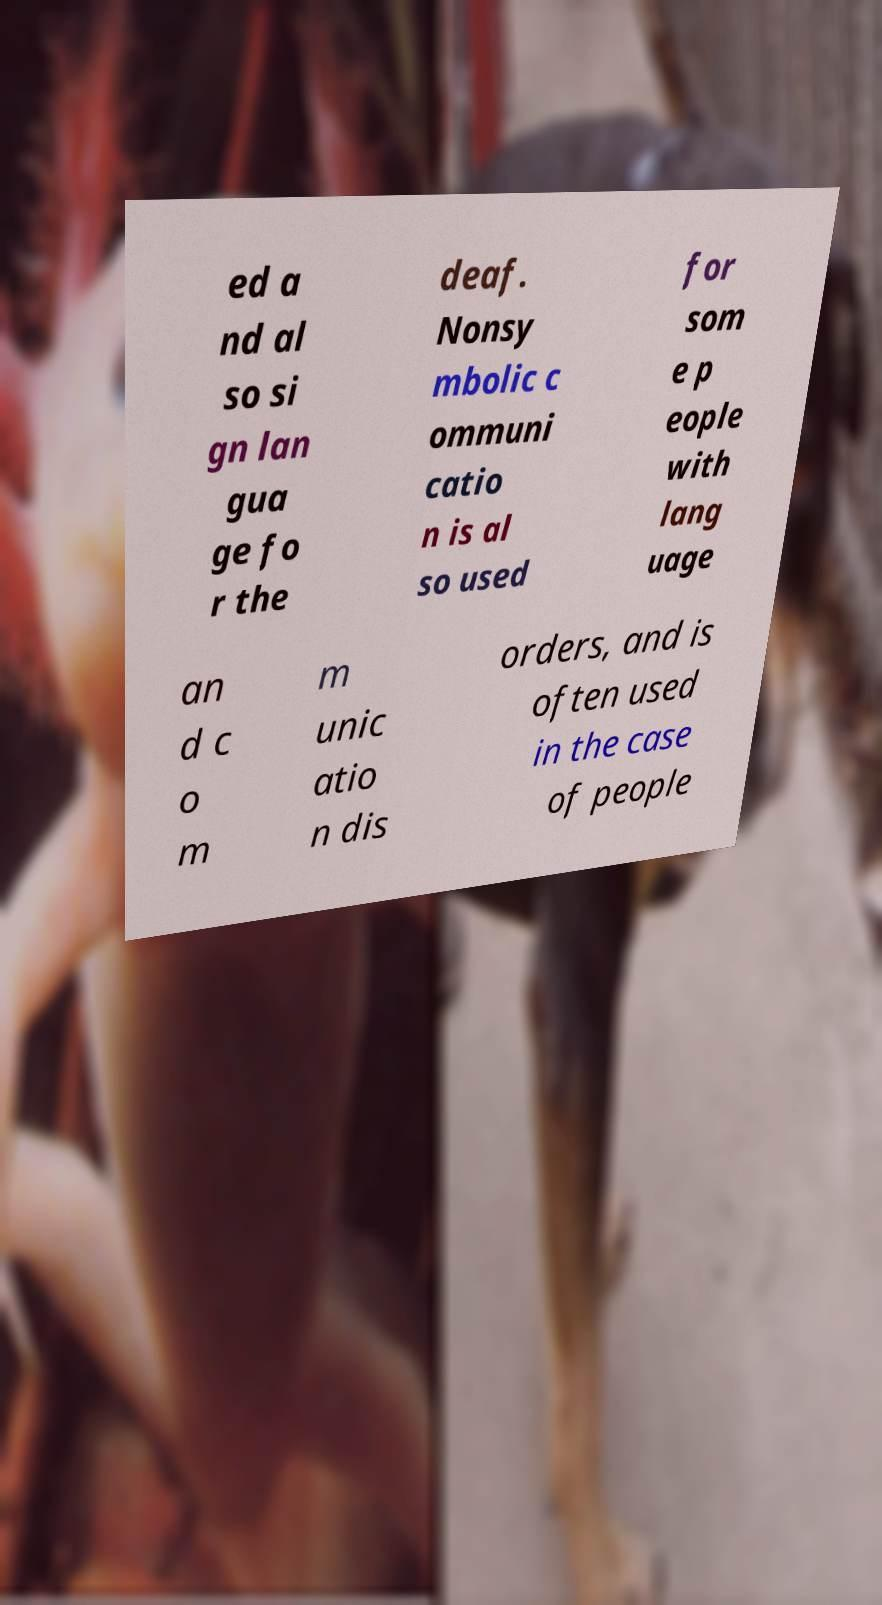Please identify and transcribe the text found in this image. ed a nd al so si gn lan gua ge fo r the deaf. Nonsy mbolic c ommuni catio n is al so used for som e p eople with lang uage an d c o m m unic atio n dis orders, and is often used in the case of people 